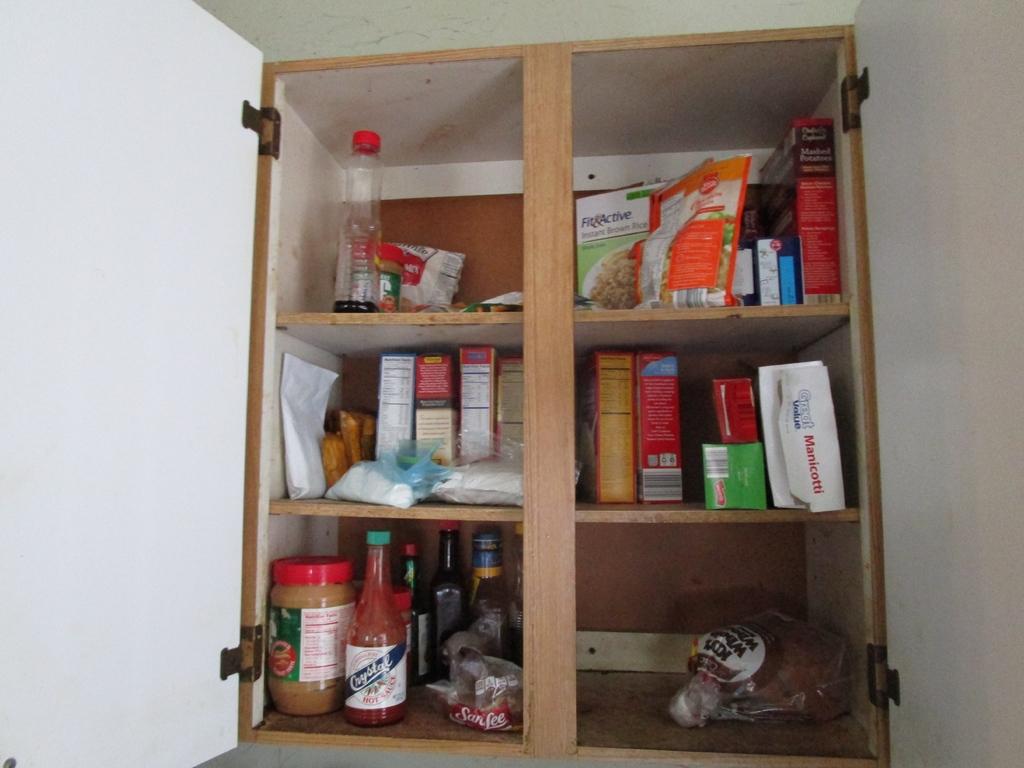What is the brand of hot sauce on the bottom left of the cabinet?
Provide a succinct answer. Crystal. 